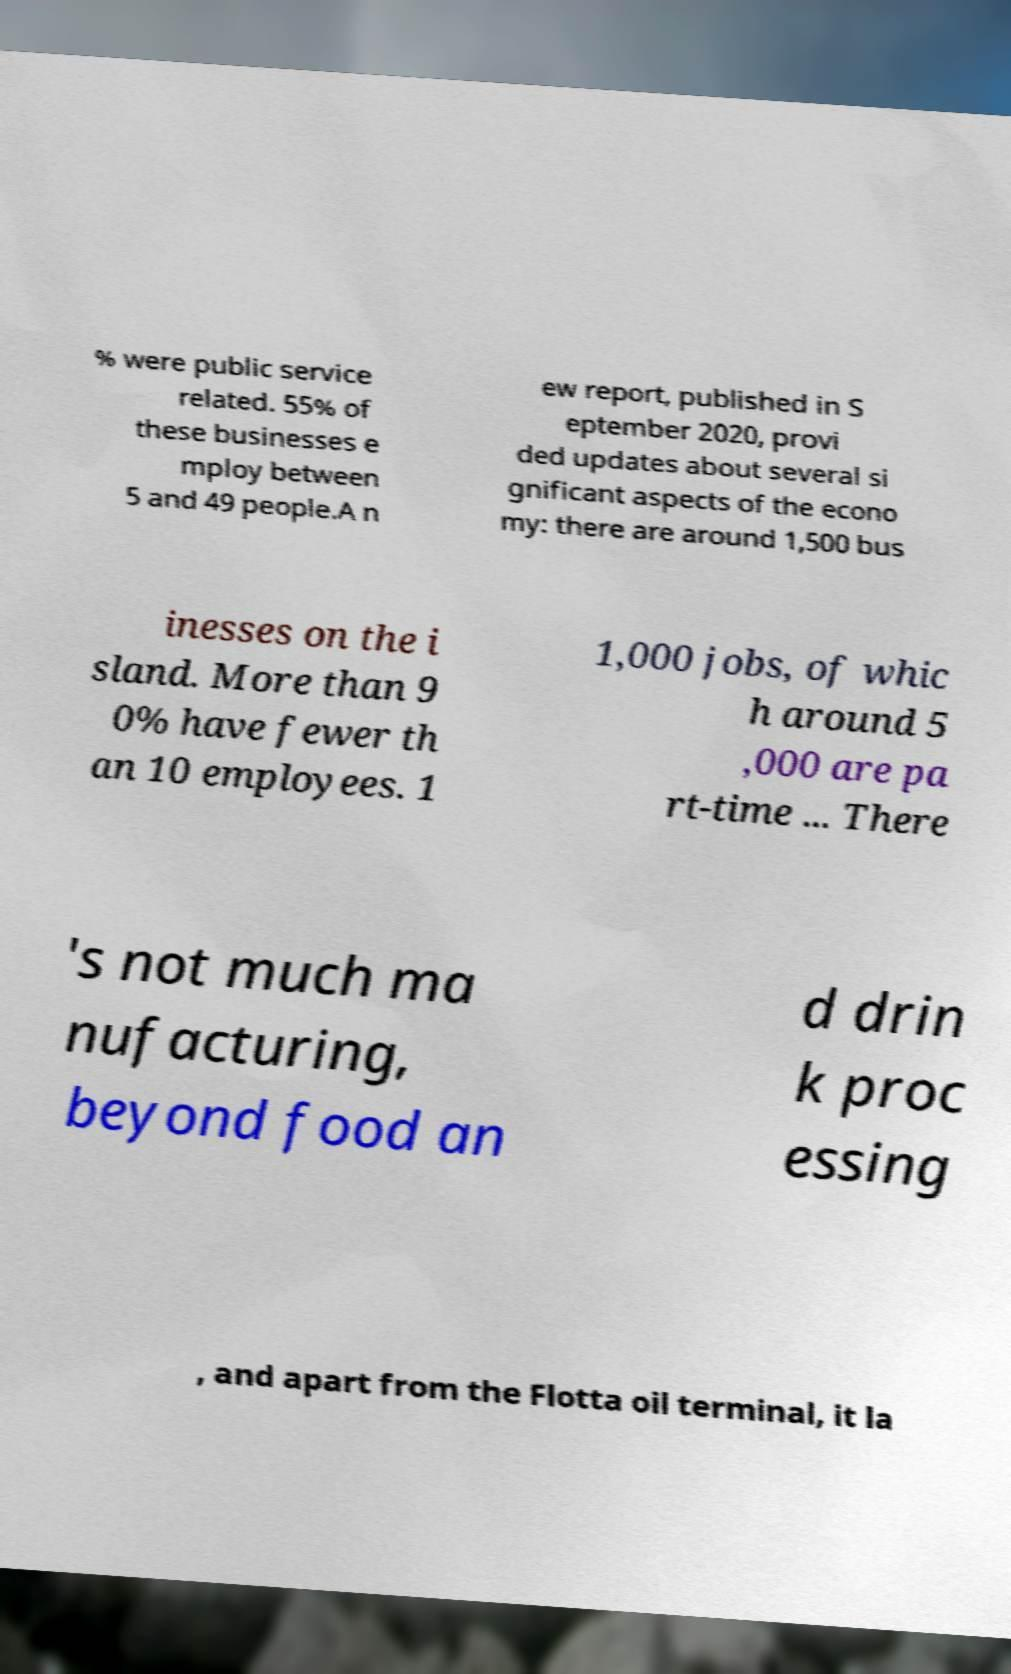What messages or text are displayed in this image? I need them in a readable, typed format. % were public service related. 55% of these businesses e mploy between 5 and 49 people.A n ew report, published in S eptember 2020, provi ded updates about several si gnificant aspects of the econo my: there are around 1,500 bus inesses on the i sland. More than 9 0% have fewer th an 10 employees. 1 1,000 jobs, of whic h around 5 ,000 are pa rt-time ... There 's not much ma nufacturing, beyond food an d drin k proc essing , and apart from the Flotta oil terminal, it la 